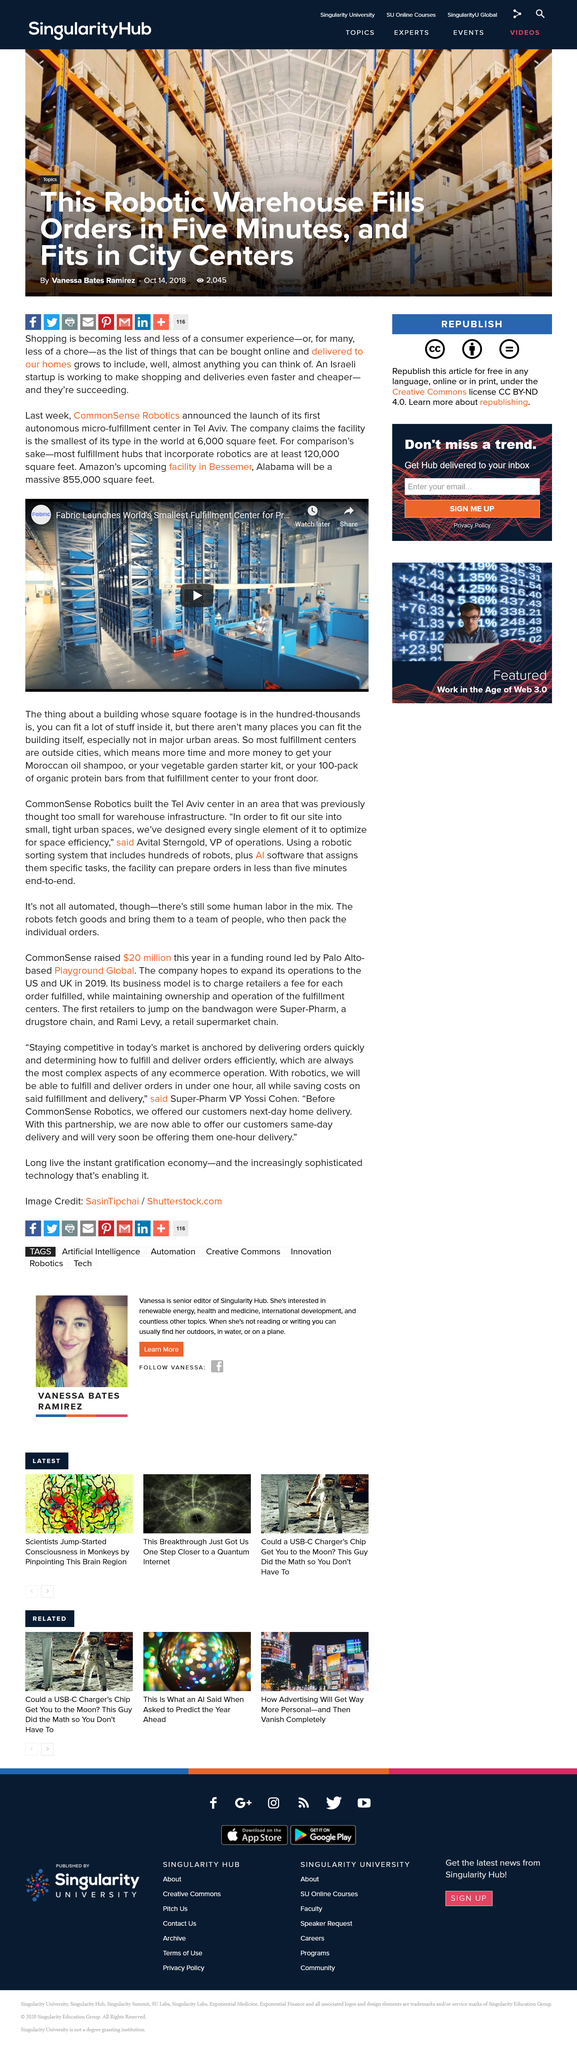Highlight a few significant elements in this photo. Amazon's upcoming fulfillment center in Bessemer, Alabama is planned to be approximately 855,000 square feet in size. Yes, there are fulfillment hubs that incorporate robotics and are located outside of cities. It has been declared that Commonsense Robotics will establish its first autonomous micro-fulfillment center in Tel-Aviv. 